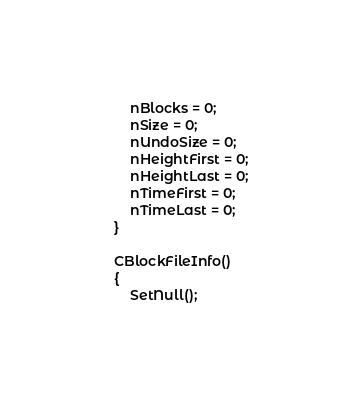<code> <loc_0><loc_0><loc_500><loc_500><_C_>        nBlocks = 0;
        nSize = 0;
        nUndoSize = 0;
        nHeightFirst = 0;
        nHeightLast = 0;
        nTimeFirst = 0;
        nTimeLast = 0;
    }

    CBlockFileInfo()
    {
        SetNull();</code> 